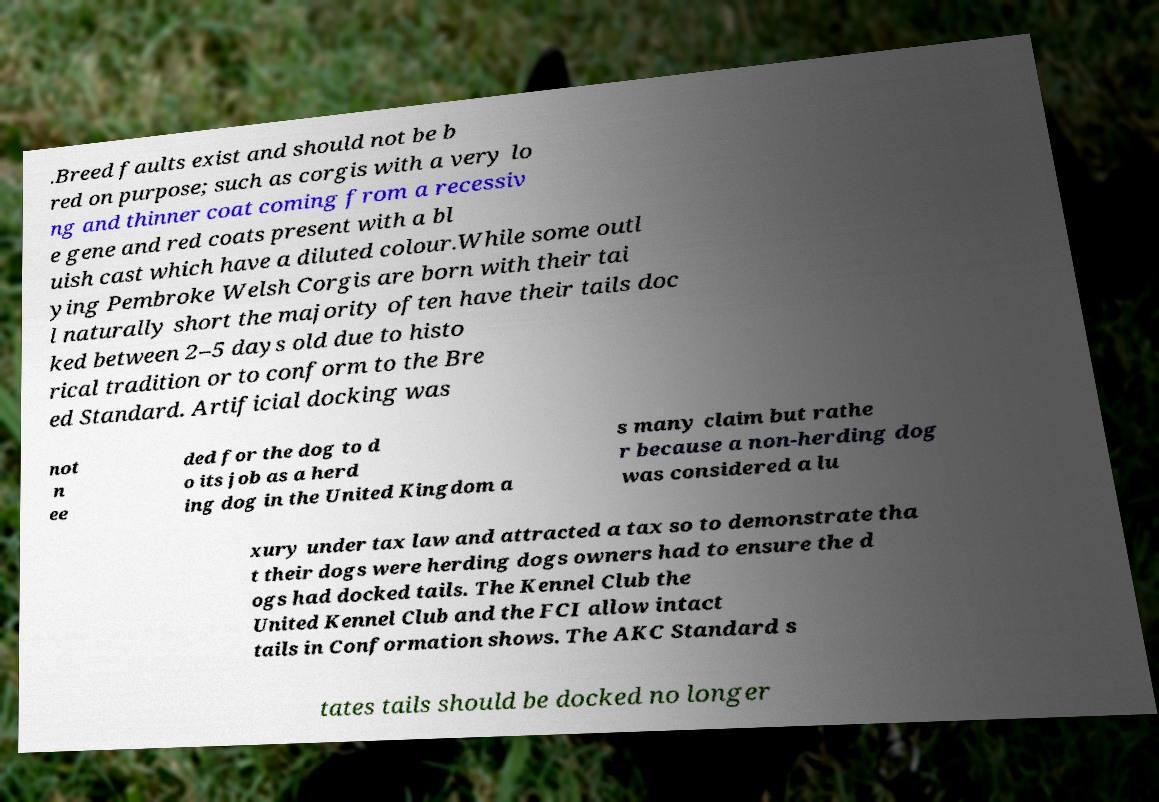Can you read and provide the text displayed in the image?This photo seems to have some interesting text. Can you extract and type it out for me? .Breed faults exist and should not be b red on purpose; such as corgis with a very lo ng and thinner coat coming from a recessiv e gene and red coats present with a bl uish cast which have a diluted colour.While some outl ying Pembroke Welsh Corgis are born with their tai l naturally short the majority often have their tails doc ked between 2–5 days old due to histo rical tradition or to conform to the Bre ed Standard. Artificial docking was not n ee ded for the dog to d o its job as a herd ing dog in the United Kingdom a s many claim but rathe r because a non-herding dog was considered a lu xury under tax law and attracted a tax so to demonstrate tha t their dogs were herding dogs owners had to ensure the d ogs had docked tails. The Kennel Club the United Kennel Club and the FCI allow intact tails in Conformation shows. The AKC Standard s tates tails should be docked no longer 